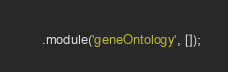<code> <loc_0><loc_0><loc_500><loc_500><_JavaScript_>    .module('geneOntology', []);</code> 